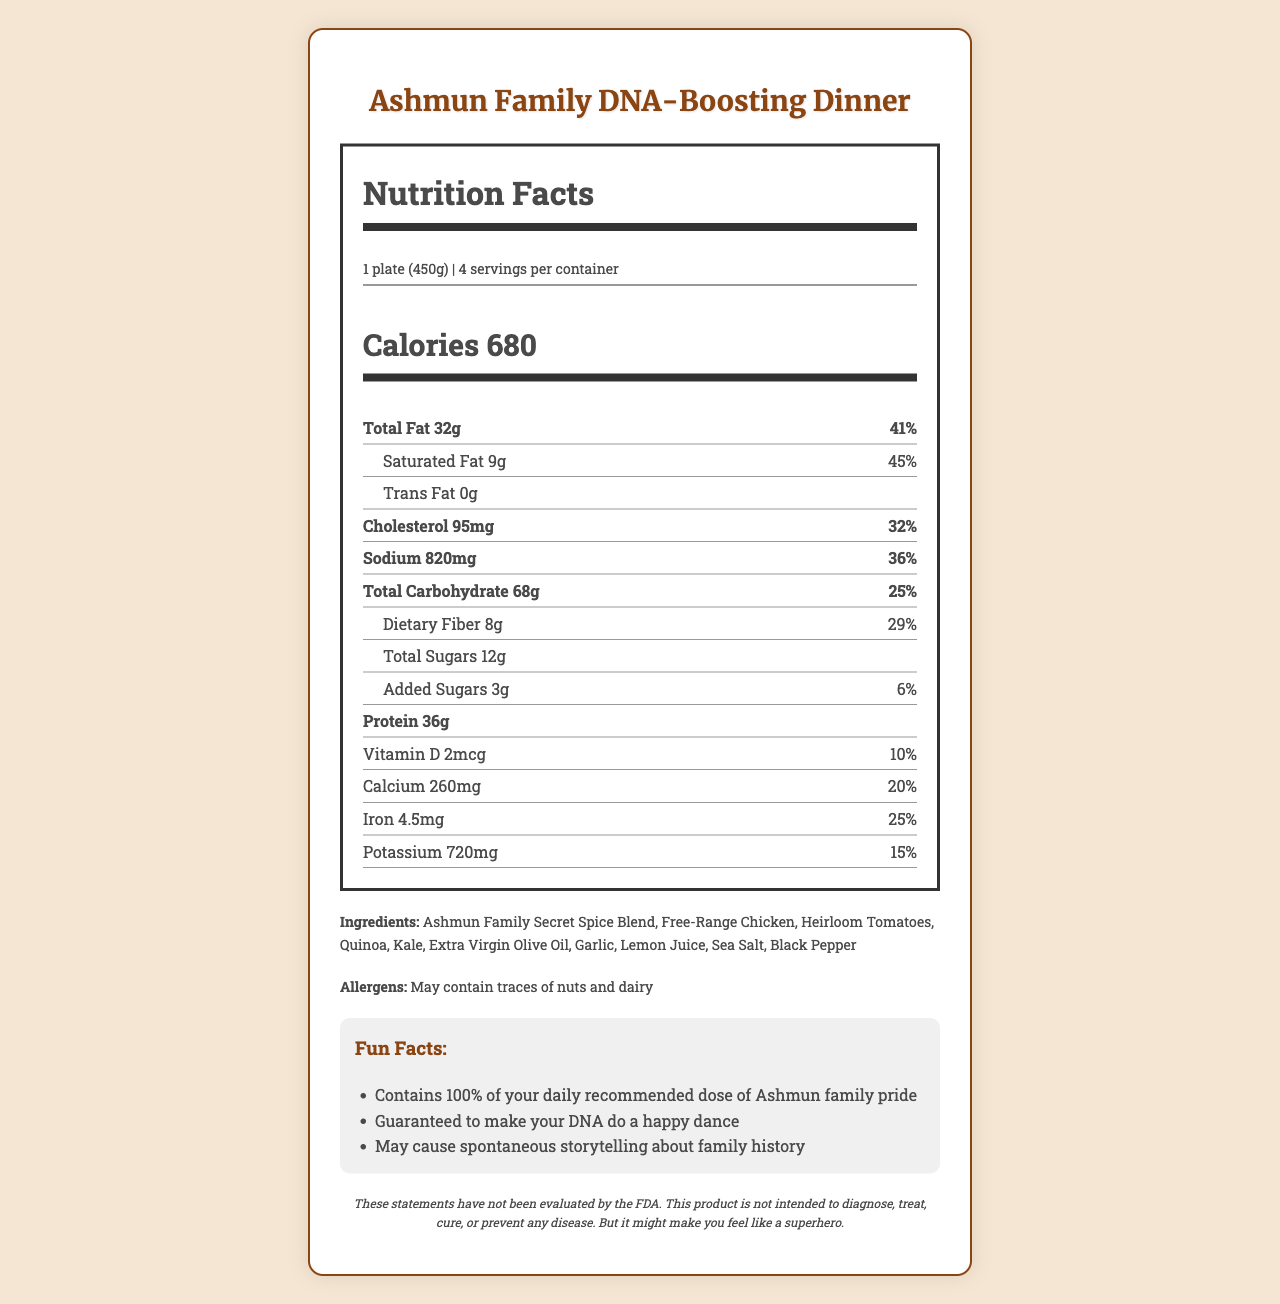what is the serving size for the Ashmun Family DNA-Boosting Dinner? The serving size is clearly listed as "1 plate (450g)" at the top of the nutrition label.
Answer: 1 plate (450g) how many servings are there per container? The label states that there are "4 servings per container."
Answer: 4 how many calories are in one serving of the Ashmun Family DNA-Boosting Dinner? The number of calories per serving is listed prominently as "680" below the serving information.
Answer: 680 what is the percentage of daily value for iron in one serving? This information is found in the nutrient section, specifically next to "Iron."
Answer: 25% what are the protein contents in a single serving? It is mentioned in the nutrient section under "Protein."
Answer: 36g which vitamin has the least percentage of daily value in one serving? Comparing the percentages of daily values for vitamins and minerals, Vitamin D has the lowest percentage at 10%.
Answer: Vitamin D (10%) how many grams of dietary fiber are in one serving? A. 6g B. 8g C. 10g The amount of dietary fiber per serving listed on the label is 8g.
Answer: B what is the total carbohydrate percentage of daily value in a single serving? A. 30% B. 28% C. 25% D. 20% The label specifies that the total carbohydrate percentage of daily value is 25%.
Answer: C are there any trans fats in the Ashmun Family DNA-Boosting Dinner? The nutrient section lists "Trans Fat 0g", indicating there are no trans fats in the product.
Answer: No does the Ashmun Family DNA-Boosting Dinner contain any allergens? The label indicates potential allergens: "May contain traces of nuts and dairy."
Answer: Yes summarize the main idea of this nutrition label. The summary encapsulates the nutritional breakdown, serving information, ingredients, allergens, and fun facts found on the label.
Answer: This document provides the nutritional information for the Ashmun Family DNA-Boosting Dinner. Each serving (1 plate, 450g) has detailed nutritional content and daily values, including calories (680), fats (32g), carbs (68g), and protein (36g). It also includes a list of ingredients, potential allergens, and fun facts related to family heritage. what ingredient is listed first in the Ashmun Family DNA-Boosting Dinner? The ingredients are listed in order and the first ingredient mentioned is "Ashmun Family Secret Spice Blend."
Answer: Ashmun Family Secret Spice Blend how much sodium does one serving contain? The sodium content for one serving is listed as "820mg."
Answer: 820mg what is the main purpose of this product as indicated in the document? The document blends detailed nutritional information with fun facts about the Ashmun family, highlighting both health and heritage.
Answer: To provide a nutritious meal with a playful emphasis on family heritage and pride. what type of fat has the highest daily value percentage? A. Saturated Fat B. Trans Fat C. Total Fat Saturated Fat has the highest daily value percentage at 45%, which is higher than Total Fat at 41% and Trans Fat at 0%.
Answer: A what are the main ingredients in the Ashmun Family DNA-Boosting Dinner? The listed ingredients in the document enumerate these components specifically.
Answer: Ashmun Family Secret Spice Blend, Free-Range Chicken, Heirloom Tomatoes, Quinoa, Kale, Extra Virgin Olive Oil, Garlic, Lemon Juice, Sea Salt, Black Pepper does this product contain any added sugars? The nutrient section lists "Added Sugars 3g," indicating the presence of added sugars.
Answer: Yes how is this product supposed to benefit consumers according to the fun facts? The fun facts section humorously alludes to these benefits connected with family heritage.
Answer: By providing a sense of family pride, making your DNA do a happy dance, and sparking storytelling about family history. what is the calcium content and its percentage of daily value in one serving? The calcium content is specified as "260mg" with a daily value percentage of "20%."
Answer: 260mg, 20% can we determine the price of the Ashmun Family DNA-Boosting Dinner from this document? The document provides only the nutritional information and does not include any pricing details.
Answer: Not enough information 